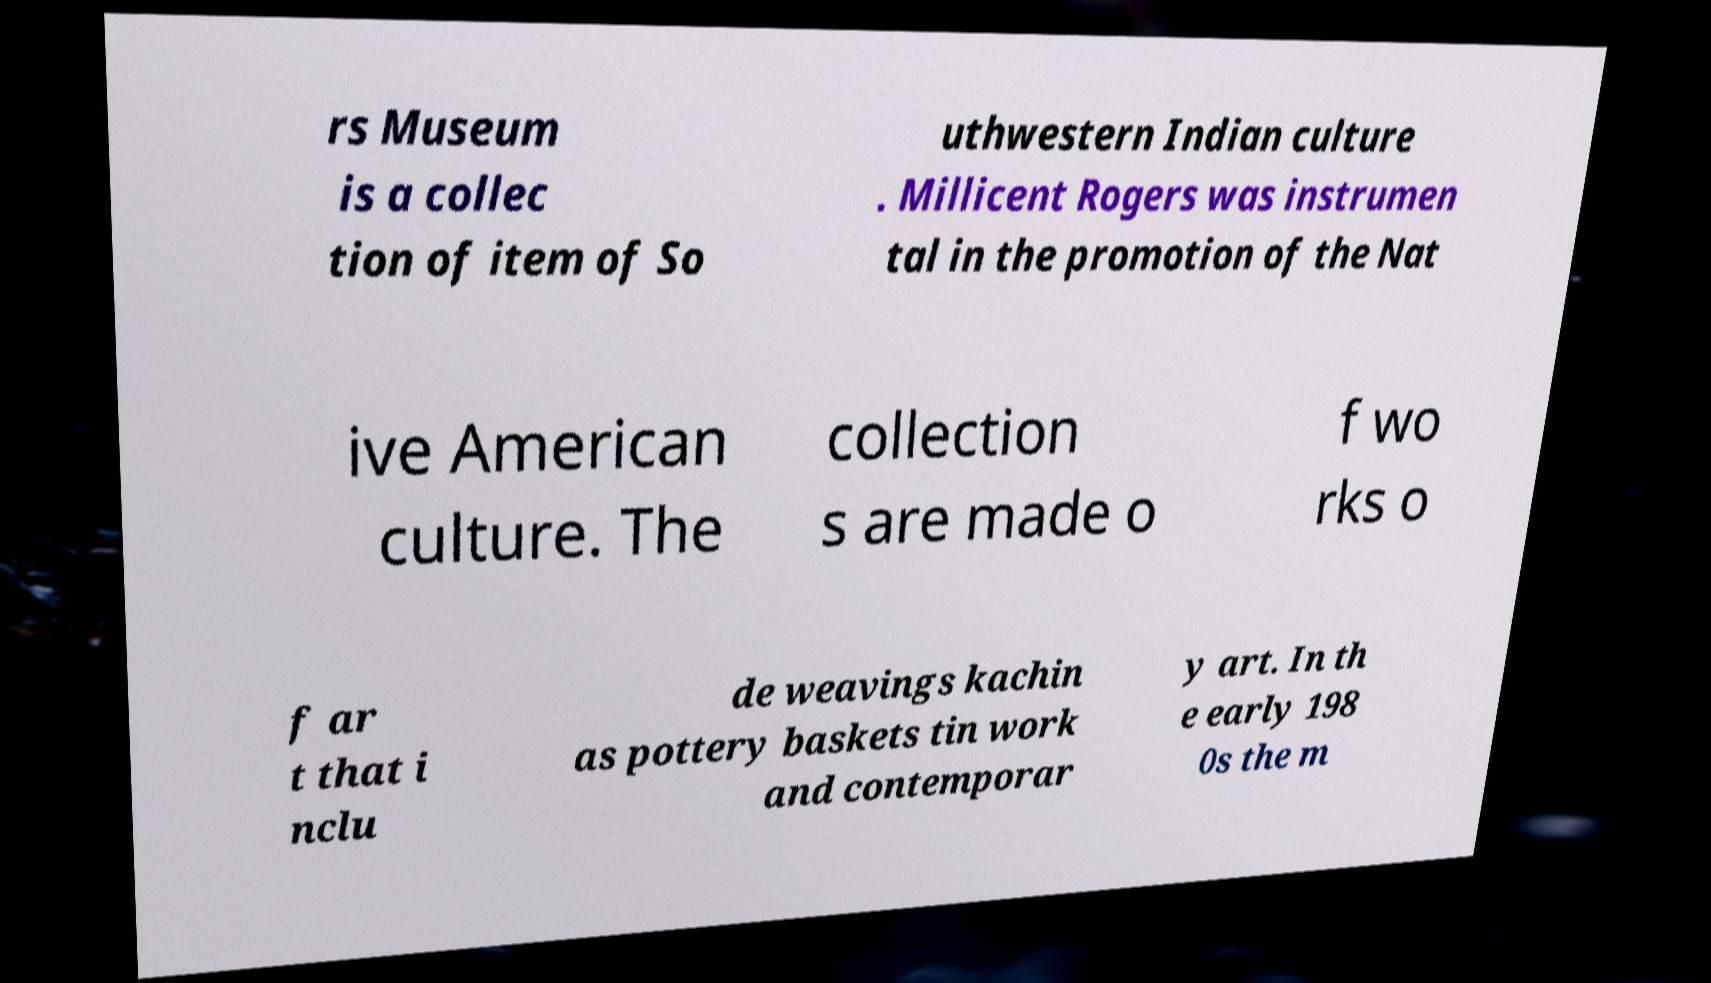Please identify and transcribe the text found in this image. rs Museum is a collec tion of item of So uthwestern Indian culture . Millicent Rogers was instrumen tal in the promotion of the Nat ive American culture. The collection s are made o f wo rks o f ar t that i nclu de weavings kachin as pottery baskets tin work and contemporar y art. In th e early 198 0s the m 